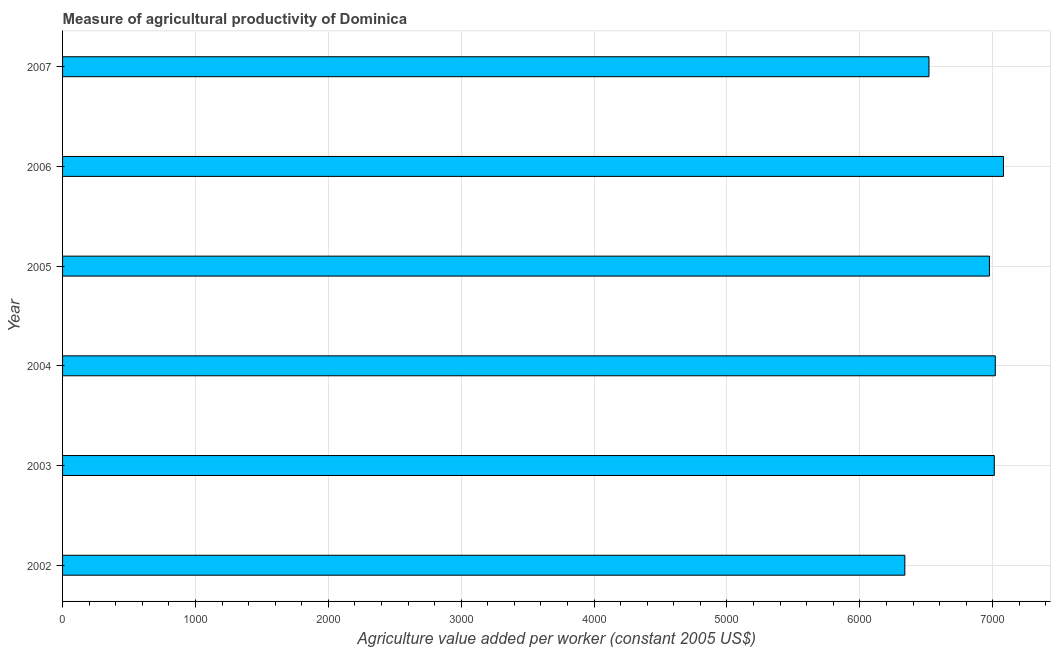Does the graph contain any zero values?
Give a very brief answer. No. Does the graph contain grids?
Provide a succinct answer. Yes. What is the title of the graph?
Your response must be concise. Measure of agricultural productivity of Dominica. What is the label or title of the X-axis?
Ensure brevity in your answer.  Agriculture value added per worker (constant 2005 US$). What is the agriculture value added per worker in 2007?
Your answer should be compact. 6520.3. Across all years, what is the maximum agriculture value added per worker?
Offer a very short reply. 7080.73. Across all years, what is the minimum agriculture value added per worker?
Make the answer very short. 6338.55. In which year was the agriculture value added per worker maximum?
Give a very brief answer. 2006. In which year was the agriculture value added per worker minimum?
Provide a short and direct response. 2002. What is the sum of the agriculture value added per worker?
Your answer should be compact. 4.09e+04. What is the difference between the agriculture value added per worker in 2004 and 2006?
Your answer should be very brief. -61.39. What is the average agriculture value added per worker per year?
Your answer should be very brief. 6824.34. What is the median agriculture value added per worker?
Provide a succinct answer. 6993.54. In how many years, is the agriculture value added per worker greater than 5000 US$?
Provide a succinct answer. 6. Do a majority of the years between 2002 and 2003 (inclusive) have agriculture value added per worker greater than 4400 US$?
Your answer should be very brief. Yes. Is the agriculture value added per worker in 2005 less than that in 2006?
Ensure brevity in your answer.  Yes. What is the difference between the highest and the second highest agriculture value added per worker?
Offer a very short reply. 61.39. What is the difference between the highest and the lowest agriculture value added per worker?
Make the answer very short. 742.18. In how many years, is the agriculture value added per worker greater than the average agriculture value added per worker taken over all years?
Offer a terse response. 4. How many bars are there?
Ensure brevity in your answer.  6. Are all the bars in the graph horizontal?
Your answer should be very brief. Yes. How many years are there in the graph?
Offer a terse response. 6. What is the Agriculture value added per worker (constant 2005 US$) of 2002?
Offer a very short reply. 6338.55. What is the Agriculture value added per worker (constant 2005 US$) in 2003?
Your response must be concise. 7011.78. What is the Agriculture value added per worker (constant 2005 US$) of 2004?
Provide a short and direct response. 7019.34. What is the Agriculture value added per worker (constant 2005 US$) in 2005?
Make the answer very short. 6975.31. What is the Agriculture value added per worker (constant 2005 US$) in 2006?
Keep it short and to the point. 7080.73. What is the Agriculture value added per worker (constant 2005 US$) in 2007?
Your answer should be compact. 6520.3. What is the difference between the Agriculture value added per worker (constant 2005 US$) in 2002 and 2003?
Provide a succinct answer. -673.23. What is the difference between the Agriculture value added per worker (constant 2005 US$) in 2002 and 2004?
Keep it short and to the point. -680.79. What is the difference between the Agriculture value added per worker (constant 2005 US$) in 2002 and 2005?
Your response must be concise. -636.76. What is the difference between the Agriculture value added per worker (constant 2005 US$) in 2002 and 2006?
Your answer should be compact. -742.18. What is the difference between the Agriculture value added per worker (constant 2005 US$) in 2002 and 2007?
Offer a very short reply. -181.75. What is the difference between the Agriculture value added per worker (constant 2005 US$) in 2003 and 2004?
Provide a short and direct response. -7.56. What is the difference between the Agriculture value added per worker (constant 2005 US$) in 2003 and 2005?
Provide a succinct answer. 36.47. What is the difference between the Agriculture value added per worker (constant 2005 US$) in 2003 and 2006?
Make the answer very short. -68.95. What is the difference between the Agriculture value added per worker (constant 2005 US$) in 2003 and 2007?
Ensure brevity in your answer.  491.48. What is the difference between the Agriculture value added per worker (constant 2005 US$) in 2004 and 2005?
Your answer should be very brief. 44.03. What is the difference between the Agriculture value added per worker (constant 2005 US$) in 2004 and 2006?
Your answer should be compact. -61.39. What is the difference between the Agriculture value added per worker (constant 2005 US$) in 2004 and 2007?
Provide a short and direct response. 499.04. What is the difference between the Agriculture value added per worker (constant 2005 US$) in 2005 and 2006?
Your response must be concise. -105.42. What is the difference between the Agriculture value added per worker (constant 2005 US$) in 2005 and 2007?
Ensure brevity in your answer.  455.01. What is the difference between the Agriculture value added per worker (constant 2005 US$) in 2006 and 2007?
Offer a very short reply. 560.43. What is the ratio of the Agriculture value added per worker (constant 2005 US$) in 2002 to that in 2003?
Keep it short and to the point. 0.9. What is the ratio of the Agriculture value added per worker (constant 2005 US$) in 2002 to that in 2004?
Make the answer very short. 0.9. What is the ratio of the Agriculture value added per worker (constant 2005 US$) in 2002 to that in 2005?
Provide a succinct answer. 0.91. What is the ratio of the Agriculture value added per worker (constant 2005 US$) in 2002 to that in 2006?
Keep it short and to the point. 0.9. What is the ratio of the Agriculture value added per worker (constant 2005 US$) in 2002 to that in 2007?
Provide a short and direct response. 0.97. What is the ratio of the Agriculture value added per worker (constant 2005 US$) in 2003 to that in 2004?
Provide a short and direct response. 1. What is the ratio of the Agriculture value added per worker (constant 2005 US$) in 2003 to that in 2005?
Offer a terse response. 1. What is the ratio of the Agriculture value added per worker (constant 2005 US$) in 2003 to that in 2007?
Provide a short and direct response. 1.07. What is the ratio of the Agriculture value added per worker (constant 2005 US$) in 2004 to that in 2007?
Offer a terse response. 1.08. What is the ratio of the Agriculture value added per worker (constant 2005 US$) in 2005 to that in 2007?
Keep it short and to the point. 1.07. What is the ratio of the Agriculture value added per worker (constant 2005 US$) in 2006 to that in 2007?
Your answer should be compact. 1.09. 